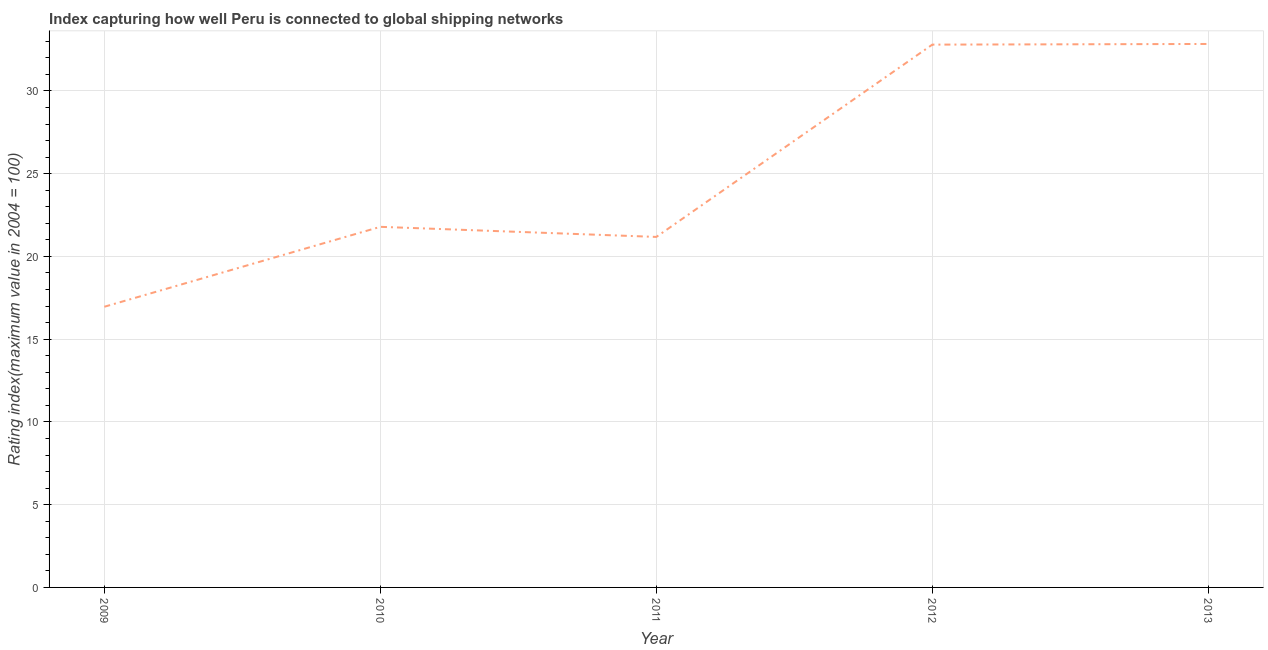What is the liner shipping connectivity index in 2012?
Make the answer very short. 32.8. Across all years, what is the maximum liner shipping connectivity index?
Make the answer very short. 32.84. Across all years, what is the minimum liner shipping connectivity index?
Offer a terse response. 16.96. In which year was the liner shipping connectivity index maximum?
Offer a terse response. 2013. What is the sum of the liner shipping connectivity index?
Offer a terse response. 125.57. What is the difference between the liner shipping connectivity index in 2010 and 2011?
Your response must be concise. 0.61. What is the average liner shipping connectivity index per year?
Offer a terse response. 25.11. What is the median liner shipping connectivity index?
Offer a terse response. 21.79. Do a majority of the years between 2013 and 2009 (inclusive) have liner shipping connectivity index greater than 3 ?
Make the answer very short. Yes. What is the ratio of the liner shipping connectivity index in 2010 to that in 2013?
Offer a very short reply. 0.66. Is the difference between the liner shipping connectivity index in 2009 and 2012 greater than the difference between any two years?
Provide a succinct answer. No. What is the difference between the highest and the second highest liner shipping connectivity index?
Ensure brevity in your answer.  0.04. Is the sum of the liner shipping connectivity index in 2009 and 2011 greater than the maximum liner shipping connectivity index across all years?
Provide a succinct answer. Yes. What is the difference between the highest and the lowest liner shipping connectivity index?
Provide a succinct answer. 15.88. In how many years, is the liner shipping connectivity index greater than the average liner shipping connectivity index taken over all years?
Provide a succinct answer. 2. What is the difference between two consecutive major ticks on the Y-axis?
Provide a succinct answer. 5. What is the title of the graph?
Offer a terse response. Index capturing how well Peru is connected to global shipping networks. What is the label or title of the Y-axis?
Your answer should be compact. Rating index(maximum value in 2004 = 100). What is the Rating index(maximum value in 2004 = 100) in 2009?
Keep it short and to the point. 16.96. What is the Rating index(maximum value in 2004 = 100) in 2010?
Offer a terse response. 21.79. What is the Rating index(maximum value in 2004 = 100) in 2011?
Ensure brevity in your answer.  21.18. What is the Rating index(maximum value in 2004 = 100) in 2012?
Provide a short and direct response. 32.8. What is the Rating index(maximum value in 2004 = 100) in 2013?
Your answer should be compact. 32.84. What is the difference between the Rating index(maximum value in 2004 = 100) in 2009 and 2010?
Provide a short and direct response. -4.83. What is the difference between the Rating index(maximum value in 2004 = 100) in 2009 and 2011?
Offer a very short reply. -4.22. What is the difference between the Rating index(maximum value in 2004 = 100) in 2009 and 2012?
Keep it short and to the point. -15.84. What is the difference between the Rating index(maximum value in 2004 = 100) in 2009 and 2013?
Your response must be concise. -15.88. What is the difference between the Rating index(maximum value in 2004 = 100) in 2010 and 2011?
Keep it short and to the point. 0.61. What is the difference between the Rating index(maximum value in 2004 = 100) in 2010 and 2012?
Your answer should be compact. -11.01. What is the difference between the Rating index(maximum value in 2004 = 100) in 2010 and 2013?
Your answer should be very brief. -11.05. What is the difference between the Rating index(maximum value in 2004 = 100) in 2011 and 2012?
Make the answer very short. -11.62. What is the difference between the Rating index(maximum value in 2004 = 100) in 2011 and 2013?
Your answer should be very brief. -11.66. What is the difference between the Rating index(maximum value in 2004 = 100) in 2012 and 2013?
Make the answer very short. -0.04. What is the ratio of the Rating index(maximum value in 2004 = 100) in 2009 to that in 2010?
Offer a very short reply. 0.78. What is the ratio of the Rating index(maximum value in 2004 = 100) in 2009 to that in 2011?
Keep it short and to the point. 0.8. What is the ratio of the Rating index(maximum value in 2004 = 100) in 2009 to that in 2012?
Your answer should be very brief. 0.52. What is the ratio of the Rating index(maximum value in 2004 = 100) in 2009 to that in 2013?
Provide a succinct answer. 0.52. What is the ratio of the Rating index(maximum value in 2004 = 100) in 2010 to that in 2012?
Ensure brevity in your answer.  0.66. What is the ratio of the Rating index(maximum value in 2004 = 100) in 2010 to that in 2013?
Ensure brevity in your answer.  0.66. What is the ratio of the Rating index(maximum value in 2004 = 100) in 2011 to that in 2012?
Provide a succinct answer. 0.65. What is the ratio of the Rating index(maximum value in 2004 = 100) in 2011 to that in 2013?
Offer a very short reply. 0.65. 